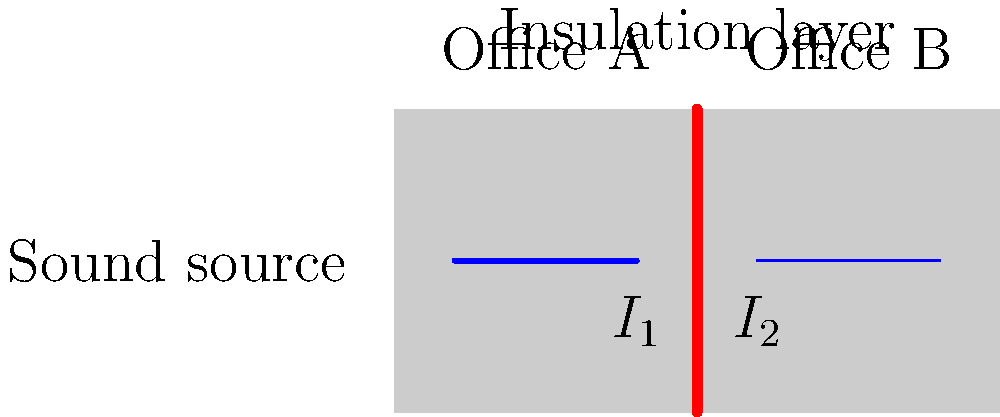As a non-profit organization director overseeing office renovations, you're considering improving sound insulation between offices. The diagram shows a cross-section of two adjacent office spaces separated by a wall with an insulation layer. If the sound intensity in Office A ($I_1$) is 80 dB, and the insulation layer reduces the sound intensity by 30 dB, what is the sound intensity ($I_2$) in Office B? To solve this problem, we need to follow these steps:

1. Understand the given information:
   - Sound intensity in Office A ($I_1$) = 80 dB
   - Insulation layer reduces sound intensity by 30 dB

2. Recognize that decibels (dB) are on a logarithmic scale, so we can't simply subtract 30 from 80.

3. Use the formula for the difference in decibels:
   $\text{dB difference} = 10 \log_{10}(\frac{I_2}{I_1})$

4. Rearrange the formula to solve for $I_2$:
   $30 = 10 \log_{10}(\frac{I_1}{I_2})$
   $3 = \log_{10}(\frac{I_1}{I_2})$
   $10^3 = \frac{I_1}{I_2}$
   $1000 = \frac{I_1}{I_2}$

5. Solve for $I_2$:
   $I_2 = \frac{I_1}{1000}$

6. Convert 80 dB to its corresponding intensity value:
   $I_1 = 10^{80/10} = 10^8$ (arbitrary units)

7. Calculate $I_2$:
   $I_2 = \frac{10^8}{1000} = 10^5$

8. Convert $I_2$ back to decibels:
   $I_2 \text{ (in dB)} = 10 \log_{10}(10^5) = 50$ dB

Therefore, the sound intensity in Office B ($I_2$) is 50 dB.
Answer: 50 dB 